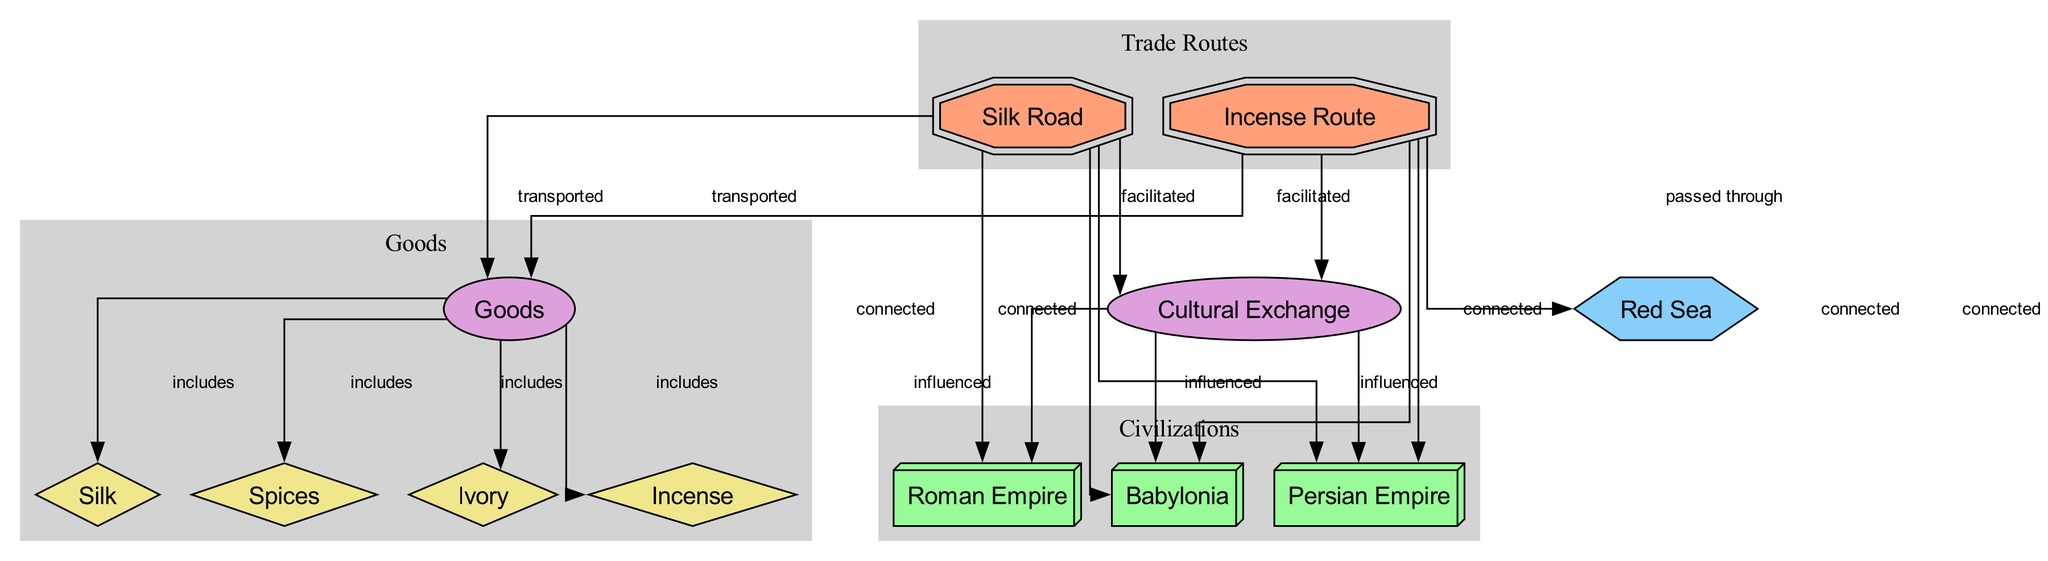What are the two main trade routes depicted in the diagram? The diagram identifies "Silk Road" and "Incense Route" as the two main trade routes. These are explicitly labeled as nodes in the diagram.
Answer: Silk Road, Incense Route Which geographical feature is featured in relation to the trade routes? The diagram includes "Red Sea" as a geographical feature, which is connected to the "Incense Route". This connection serves a specific purpose in the context of trade routes.
Answer: Red Sea How many civilizations are connected to the Silk Road? According to the diagram, the Silk Road is connected to three civilizations: Babylonia, Persian Empire, and Roman Empire. Each of these civilizations is linked directly to the Silk Road node.
Answer: 3 What goods are included in the terms of the trade routes? The goods transported include Silk, Spices, Ivory, and Incense, all of which are directly included as connected nodes to the "Goods" concept node in the diagram.
Answer: Silk, Spices, Ivory, Incense How does cultural exchange relate to the trade routes in the diagram? The diagram shows that both the Silk Road and the Incense Route facilitated "Cultural Exchange", indicating that these trade routes played a crucial role in influencing various civilizations like Babylonia, Persian Empire, and Roman Empire.
Answer: Facilitated by Silk Road and Incense Route Which civilization influenced by cultural exchange is connected through both trade routes? "Babylonia" is the civilization that is influenced by cultural exchange and is also connected to both the Silk Road and Incense Route, as evident in multiple connections illustrated in the diagram.
Answer: Babylonia What type of goods are transported via the Incense Route? The diagram specifies that the Incense Route transports the same set of goods as the Silk Road, which includes Goods like Silk, Spices, Ivory, and Incense, showing the overlap in trade goods between these routes.
Answer: Silk, Spices, Ivory, Incense Which civilization is influenced by cultural exchange but not shown as connected to the Silk Road? The diagram displays that while the Persian Empire is influenced by cultural exchange, it is not specifically connected to the Silk Road node. Instead, it is connected to the Incense Route.
Answer: Persian Empire 